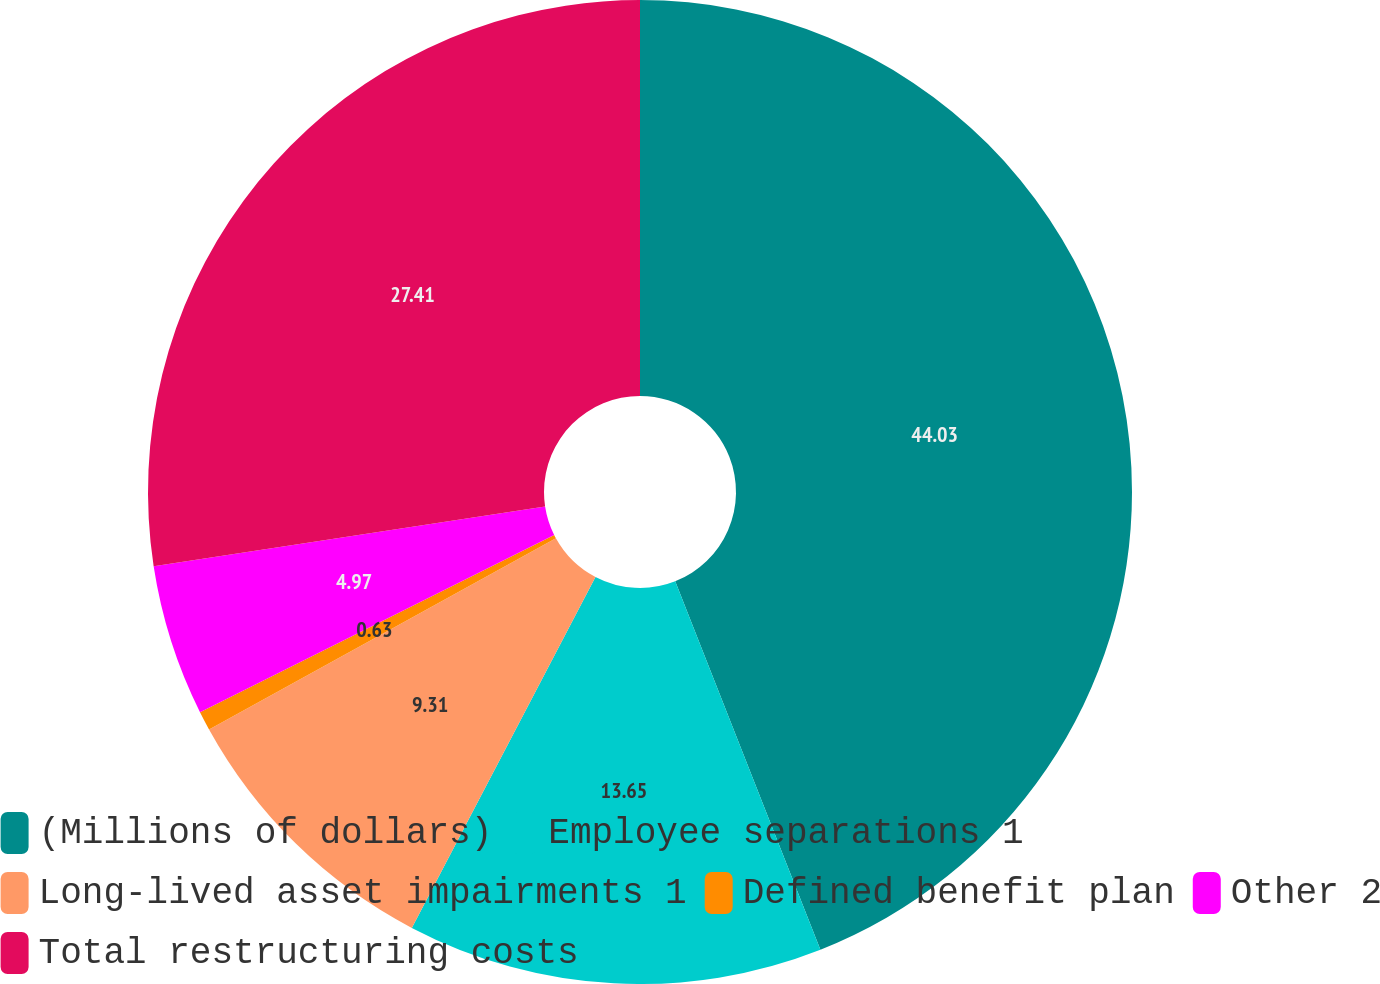Convert chart. <chart><loc_0><loc_0><loc_500><loc_500><pie_chart><fcel>(Millions of dollars)<fcel>Employee separations 1<fcel>Long-lived asset impairments 1<fcel>Defined benefit plan<fcel>Other 2<fcel>Total restructuring costs<nl><fcel>44.02%<fcel>13.65%<fcel>9.31%<fcel>0.63%<fcel>4.97%<fcel>27.41%<nl></chart> 